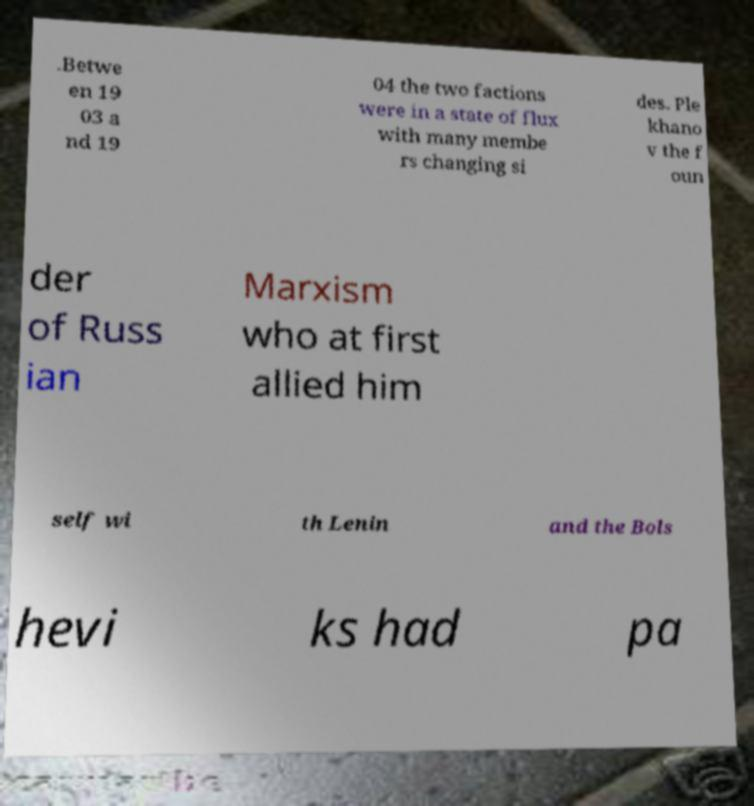Can you accurately transcribe the text from the provided image for me? .Betwe en 19 03 a nd 19 04 the two factions were in a state of flux with many membe rs changing si des. Ple khano v the f oun der of Russ ian Marxism who at first allied him self wi th Lenin and the Bols hevi ks had pa 